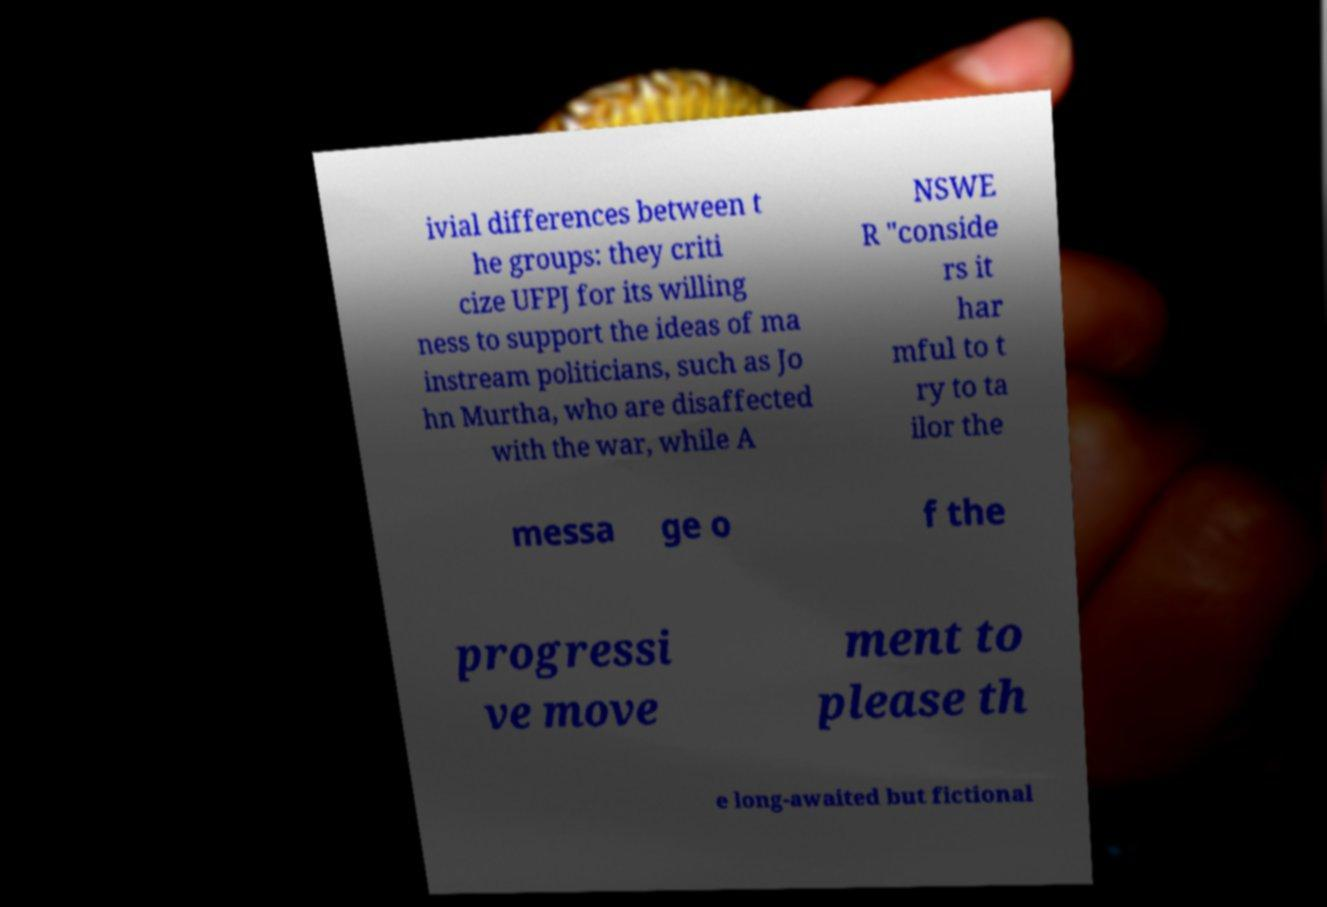Can you read and provide the text displayed in the image?This photo seems to have some interesting text. Can you extract and type it out for me? ivial differences between t he groups: they criti cize UFPJ for its willing ness to support the ideas of ma instream politicians, such as Jo hn Murtha, who are disaffected with the war, while A NSWE R "conside rs it har mful to t ry to ta ilor the messa ge o f the progressi ve move ment to please th e long-awaited but fictional 